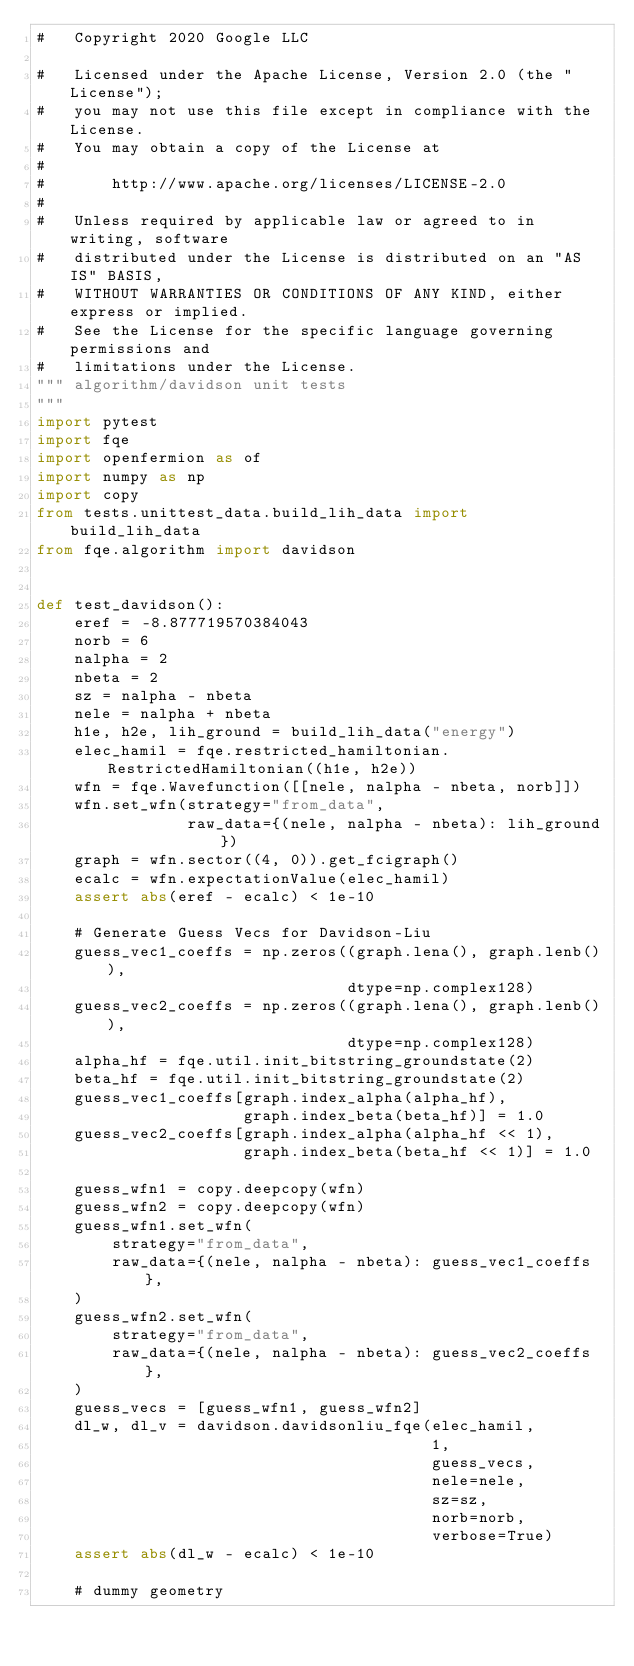Convert code to text. <code><loc_0><loc_0><loc_500><loc_500><_Python_>#   Copyright 2020 Google LLC

#   Licensed under the Apache License, Version 2.0 (the "License");
#   you may not use this file except in compliance with the License.
#   You may obtain a copy of the License at
#
#       http://www.apache.org/licenses/LICENSE-2.0
#
#   Unless required by applicable law or agreed to in writing, software
#   distributed under the License is distributed on an "AS IS" BASIS,
#   WITHOUT WARRANTIES OR CONDITIONS OF ANY KIND, either express or implied.
#   See the License for the specific language governing permissions and
#   limitations under the License.
""" algorithm/davidson unit tests
"""
import pytest
import fqe
import openfermion as of
import numpy as np
import copy
from tests.unittest_data.build_lih_data import build_lih_data
from fqe.algorithm import davidson


def test_davidson():
    eref = -8.877719570384043
    norb = 6
    nalpha = 2
    nbeta = 2
    sz = nalpha - nbeta
    nele = nalpha + nbeta
    h1e, h2e, lih_ground = build_lih_data("energy")
    elec_hamil = fqe.restricted_hamiltonian.RestrictedHamiltonian((h1e, h2e))
    wfn = fqe.Wavefunction([[nele, nalpha - nbeta, norb]])
    wfn.set_wfn(strategy="from_data",
                raw_data={(nele, nalpha - nbeta): lih_ground})
    graph = wfn.sector((4, 0)).get_fcigraph()
    ecalc = wfn.expectationValue(elec_hamil)
    assert abs(eref - ecalc) < 1e-10

    # Generate Guess Vecs for Davidson-Liu
    guess_vec1_coeffs = np.zeros((graph.lena(), graph.lenb()),
                                 dtype=np.complex128)
    guess_vec2_coeffs = np.zeros((graph.lena(), graph.lenb()),
                                 dtype=np.complex128)
    alpha_hf = fqe.util.init_bitstring_groundstate(2)
    beta_hf = fqe.util.init_bitstring_groundstate(2)
    guess_vec1_coeffs[graph.index_alpha(alpha_hf),
                      graph.index_beta(beta_hf)] = 1.0
    guess_vec2_coeffs[graph.index_alpha(alpha_hf << 1),
                      graph.index_beta(beta_hf << 1)] = 1.0

    guess_wfn1 = copy.deepcopy(wfn)
    guess_wfn2 = copy.deepcopy(wfn)
    guess_wfn1.set_wfn(
        strategy="from_data",
        raw_data={(nele, nalpha - nbeta): guess_vec1_coeffs},
    )
    guess_wfn2.set_wfn(
        strategy="from_data",
        raw_data={(nele, nalpha - nbeta): guess_vec2_coeffs},
    )
    guess_vecs = [guess_wfn1, guess_wfn2]
    dl_w, dl_v = davidson.davidsonliu_fqe(elec_hamil,
                                          1,
                                          guess_vecs,
                                          nele=nele,
                                          sz=sz,
                                          norb=norb,
                                          verbose=True)
    assert abs(dl_w - ecalc) < 1e-10

    # dummy geometry</code> 